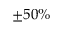<formula> <loc_0><loc_0><loc_500><loc_500>\pm 5 0 \%</formula> 